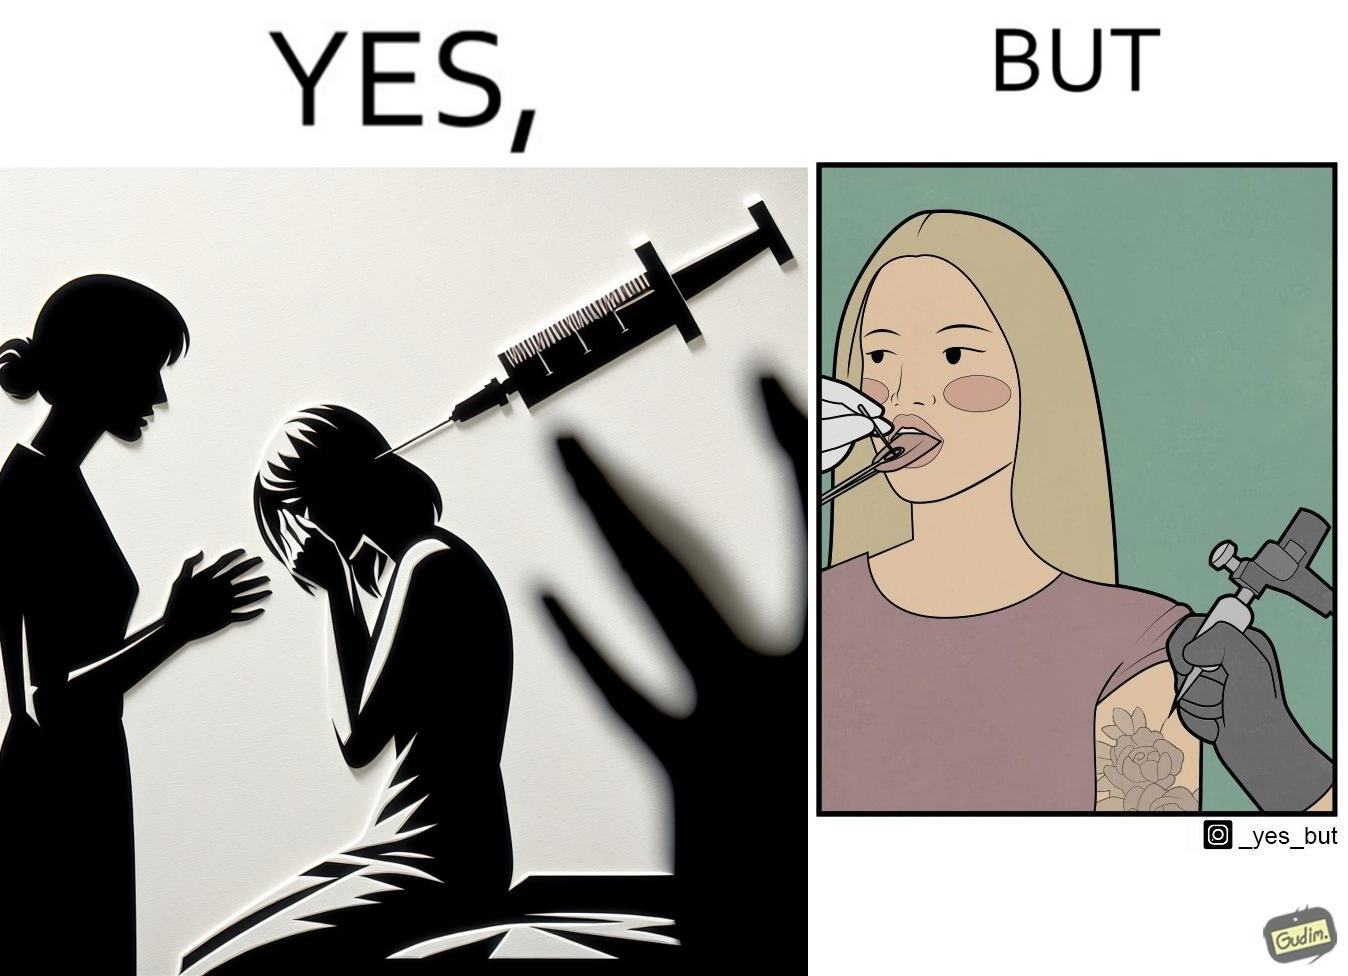Provide a description of this image. The image is funny becuase while the woman is scared of getting an injection which is for her benefit, she is not afraid of getting a piercing or a tattoo which are not going to help her in any way. 